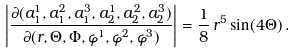Convert formula to latex. <formula><loc_0><loc_0><loc_500><loc_500>\left | \frac { \partial ( a _ { 1 } ^ { 1 } , a _ { 1 } ^ { 2 } , a _ { 1 } ^ { 3 } , a _ { 2 } ^ { 1 } , a _ { 2 } ^ { 2 } , a _ { 2 } ^ { 3 } ) } { \partial ( r , \Theta , \Phi , \varphi ^ { 1 } , \varphi ^ { 2 } , \varphi ^ { 3 } ) } \right | = \frac { 1 } { 8 } \, r ^ { 5 } \sin ( 4 \Theta ) \, .</formula> 